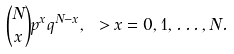Convert formula to latex. <formula><loc_0><loc_0><loc_500><loc_500>{ N \choose x } p ^ { x } q ^ { N - x } , \ > x = 0 , 1 , \dots , N .</formula> 